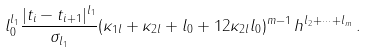<formula> <loc_0><loc_0><loc_500><loc_500>l _ { 0 } ^ { l _ { 1 } } \frac { | t _ { i } - t _ { i + 1 } | ^ { l _ { 1 } } } { \sigma _ { l _ { 1 } } } ( \kappa _ { 1 l } + \kappa _ { 2 l } + l _ { 0 } + 1 2 \kappa _ { 2 l } l _ { 0 } ) ^ { m - 1 } \, h ^ { l _ { 2 } + \cdots + l _ { m } } \, .</formula> 